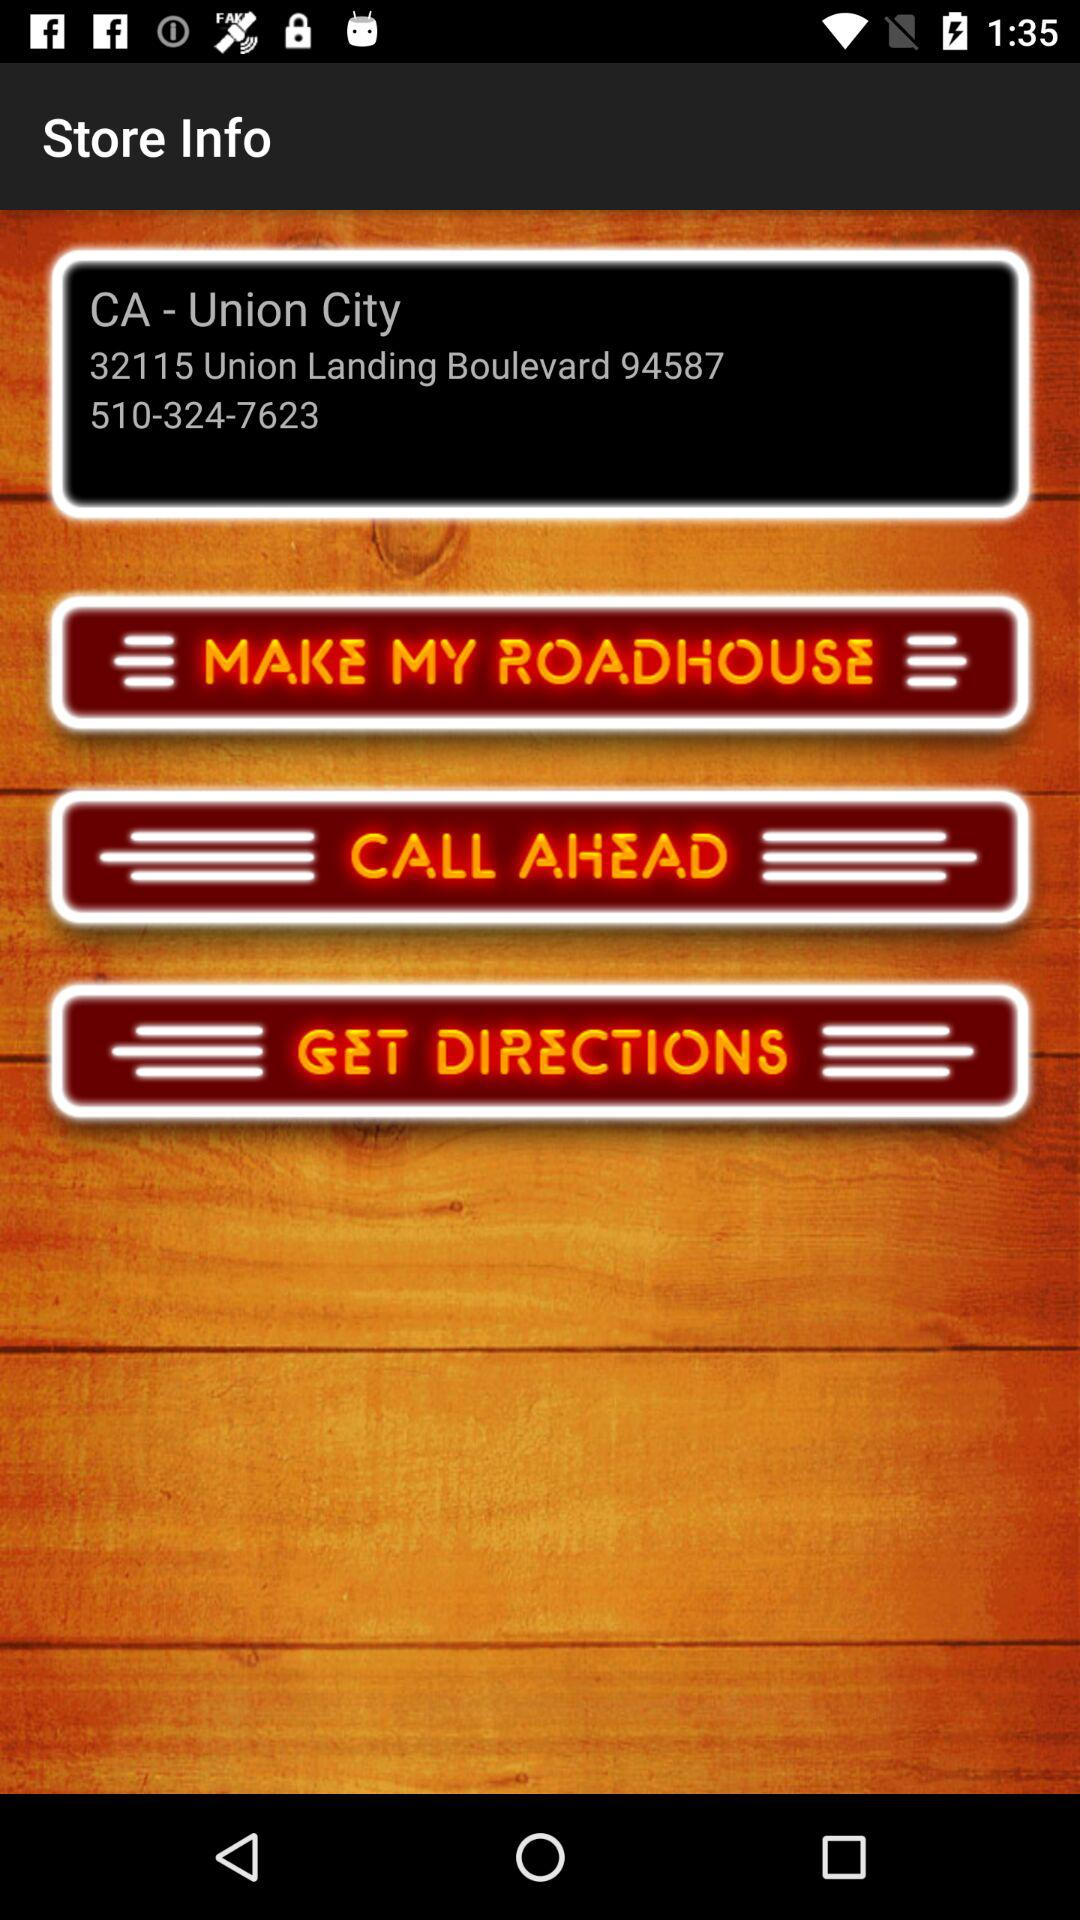What is the contact number for a store? The contact number for the store is 510-324-7623. 